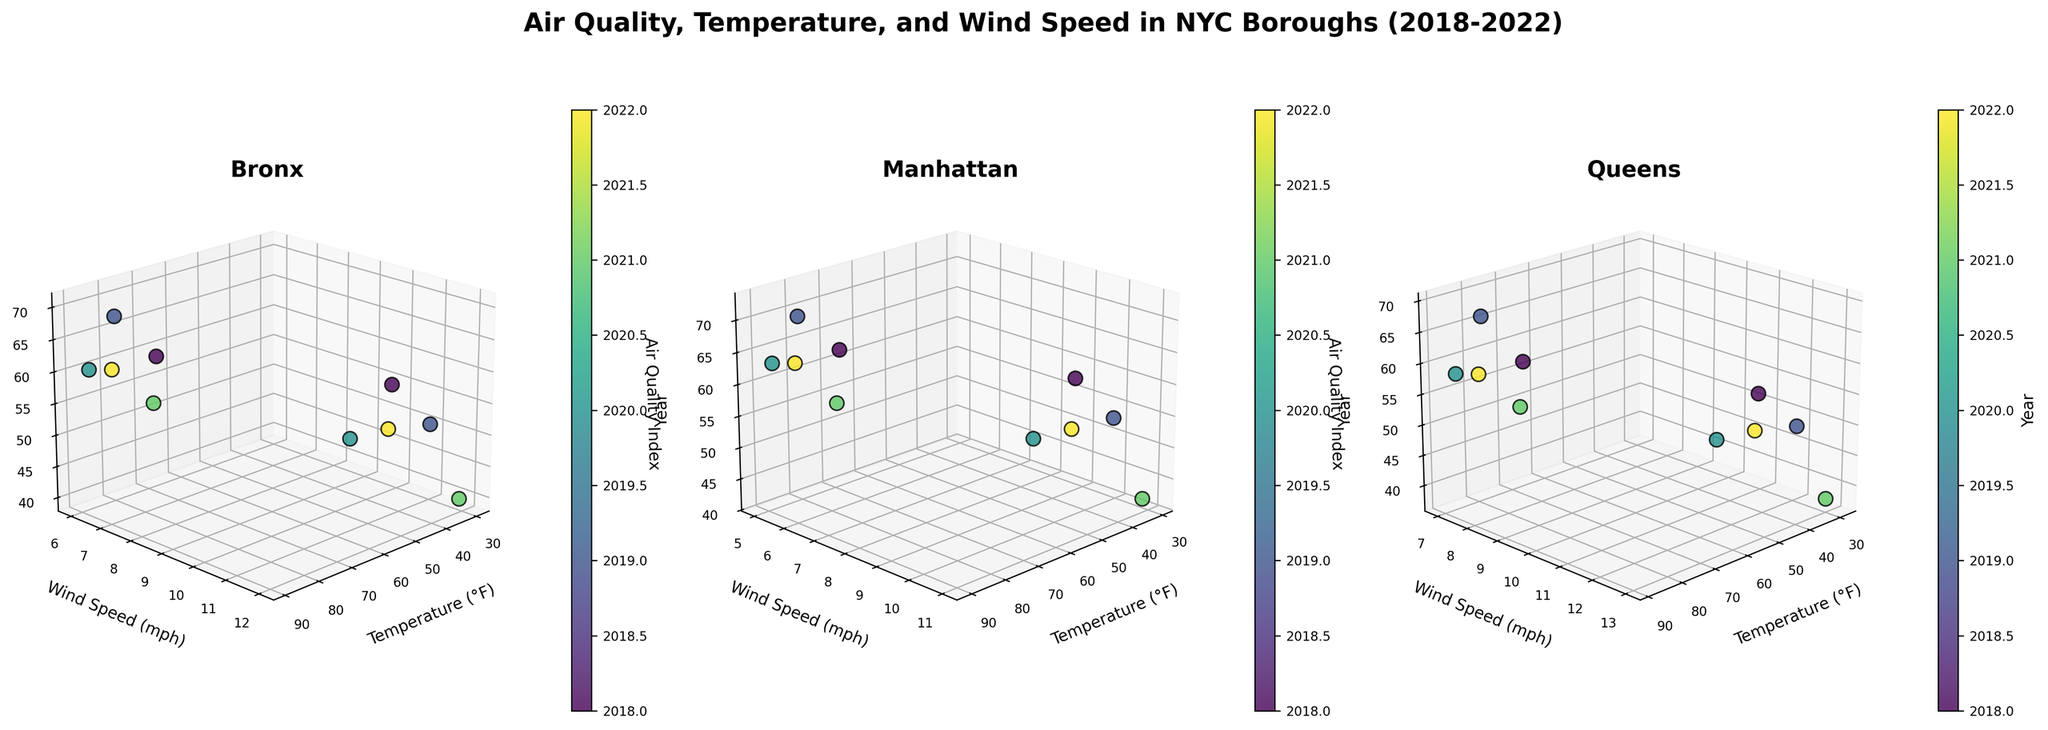Which borough has the highest AQI for July 2022? By looking at the subplot and identifying July 2022, we can observe the highest AQI among the three boroughs. The AQI values are: 62 (Bronx), 65 (Manhattan), 60 (Queens). Therefore, Manhattan has the highest AQI.
Answer: Manhattan Which borough shows the highest temperature in January 2021? Reviewing the January 2021 data points across all subplots, we observe the following temperatures: 31°F (Bronx), 32°F (Manhattan), 30°F (Queens). Thus, Manhattan has the highest temperature.
Answer: Manhattan Which borough had the lowest AQI in January over the years? Observing the subplots and focusing on January data points over the years, the AQI values are: Bronx (55, 50, 45, 40, 48), Manhattan (58, 53, 47, 42, 50), Queens (52, 48, 43, 38, 46). The lowest value is from Queens in January 2021 (38).
Answer: Queens How does the AQI trend from 2018 to 2022 for the borough of Bronx? By selecting the Bronx subplot and examining AQI values from 2018 to 2022: January: 55, 50, 45, 40, 48; July: 65, 70, 60, 58, 62. There's a general downward trend in winter and fluctuating trend in summer.
Answer: Downward in January, Fluctuating in July What's the most common air quality level for Queens in July? Let's map all AQI values in July for Queens: 63 (2018), 69 (2019), 58 (2020), 56 (2021), 60 (2022). Identify the mode: 63, 69, 58, 56, 60. All are unique, no repeating mode so there's no most common AQI.
Answer: No common AQI Which borough showed the largest variation in AQI across all years? Calculate the AQI ranges for each borough. Bronx: 65-40=25 (lowest 40 in Jan 2021, highest 70 in Jul 2019). Manhattan: 72-42=30 (lowest 42 in Jan 2021, highest 72 in Jul 2019). Queens: 69-38=31 (lowest 38 in Jan 2021, highest 69 in Jul 2019).
Answer: Queens Does the AQI in any borough correlate with temperature? Compare AQI and temperature trends for each borough: Bronx (January: AQI decreases as Temperature decreases, July: AQI fluctuates independent of Temperature), Manhattan (similar pattern), Queens (similar pattern). No obvious correlation in July, slight negative correlation in January.
Answer: Negative in January, None in July How does the 2020 AQI for Manhattan in July compare with the Bronx and Queens? Examine the 2020 subplot values for July, Manhattan: 63, Bronx: 60, Queens: 58. By comparing, Manhattan has the highest AQI followed by Bronx and Queens.
Answer: Higher What is the average wind speed in Queens over the years? Sum all wind speed values in Queens then divide by the total number of data points. January: (11+12+10+13+11=57), July: (9+8+7+9+8=41). Average = (57+41)/10 = 98/10 = 9.8 mph
Answer: 9.8 mph How does the AQI value for Bronx compare to Manhattan in January 2019? Bronx AQI in January 2019 is 50, whereas Manhattan AQI for the same period is 53. Thus, Bronx has a lower AQI compared to Manhattan.
Answer: Lower 